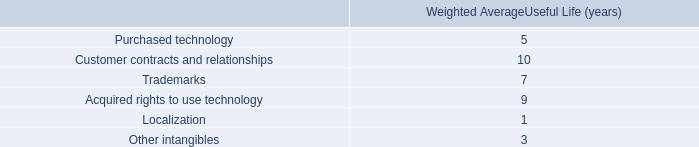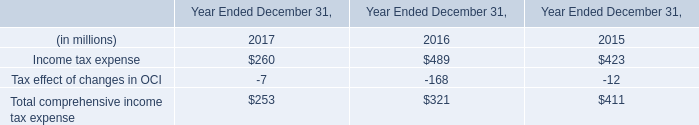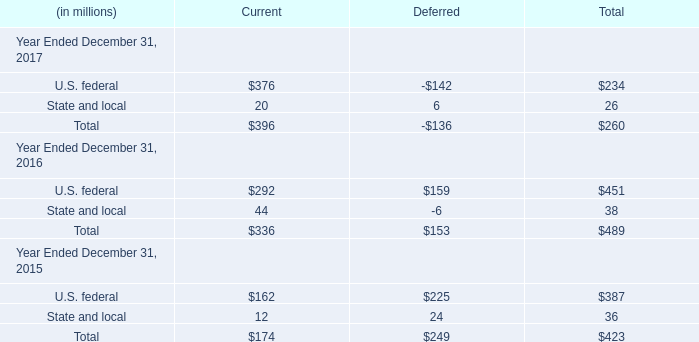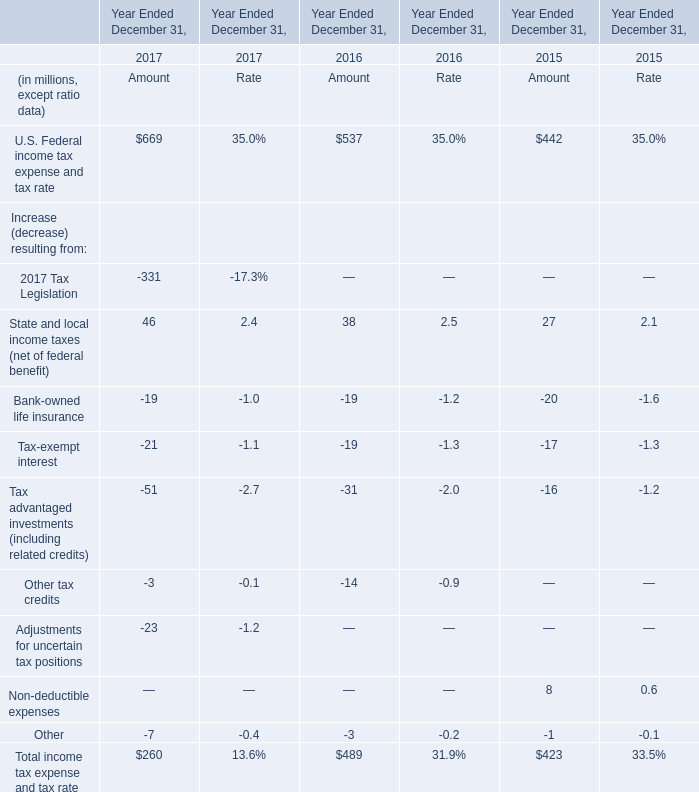In the year with lowest amount of State and local for Current , what's the increasing rate of U.S. federal for Current? 
Computations: ((376 - 292) / 292)
Answer: 0.28767. 